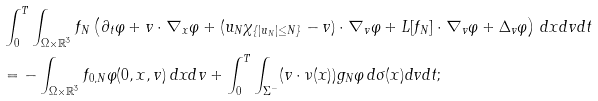<formula> <loc_0><loc_0><loc_500><loc_500>& \int ^ { T } _ { 0 } \int _ { \Omega \times \mathbb { R } ^ { 3 } } f _ { N } \left ( \partial _ { t } \varphi + v \cdot \nabla _ { x } \varphi + ( u _ { N } \chi _ { \{ | u _ { N } | \leq N \} } - v ) \cdot \nabla _ { v } \varphi + L [ f _ { N } ] \cdot \nabla _ { v } \varphi + \Delta _ { v } \varphi \right ) \, d x d v d t \\ & = - \int _ { \Omega \times \mathbb { R } ^ { 3 } } f _ { 0 , N } \varphi ( 0 , x , v ) \, d x d v + \int _ { 0 } ^ { T } \int _ { \Sigma ^ { - } } ( v \cdot \nu ( x ) ) g _ { N } \varphi \, d \sigma ( x ) d v d t ;</formula> 